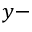<formula> <loc_0><loc_0><loc_500><loc_500>y -</formula> 